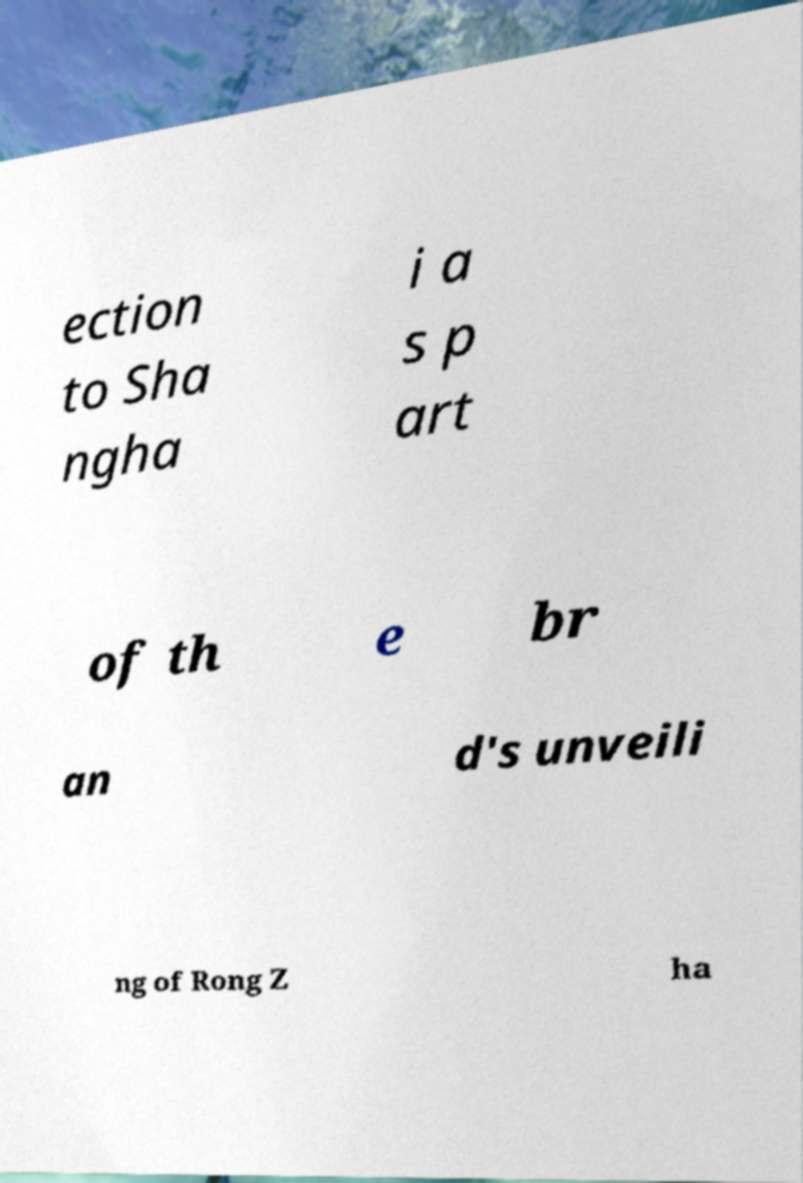What messages or text are displayed in this image? I need them in a readable, typed format. ection to Sha ngha i a s p art of th e br an d's unveili ng of Rong Z ha 